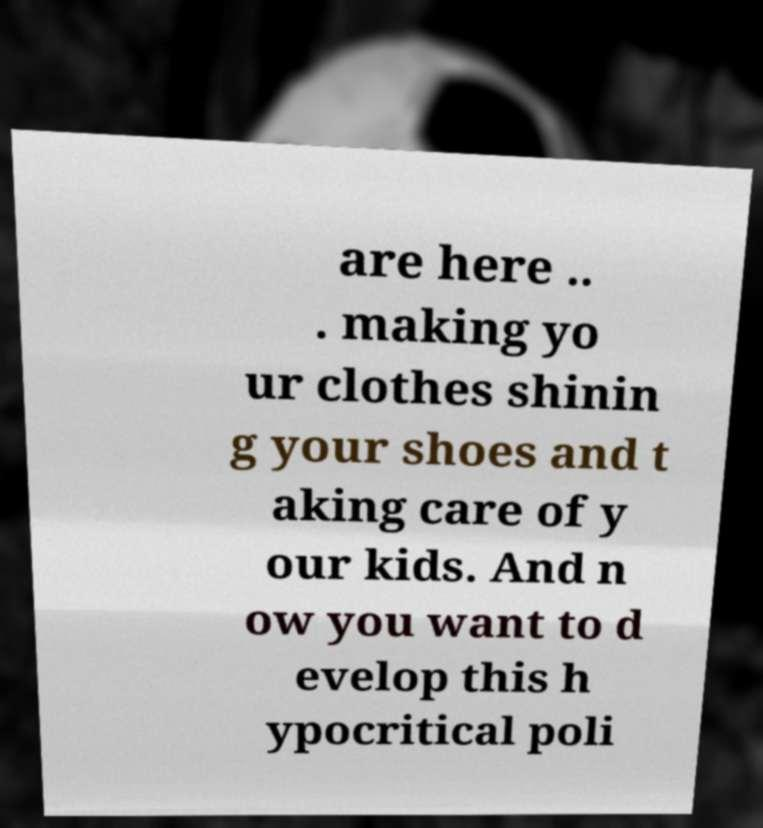Could you extract and type out the text from this image? are here .. . making yo ur clothes shinin g your shoes and t aking care of y our kids. And n ow you want to d evelop this h ypocritical poli 